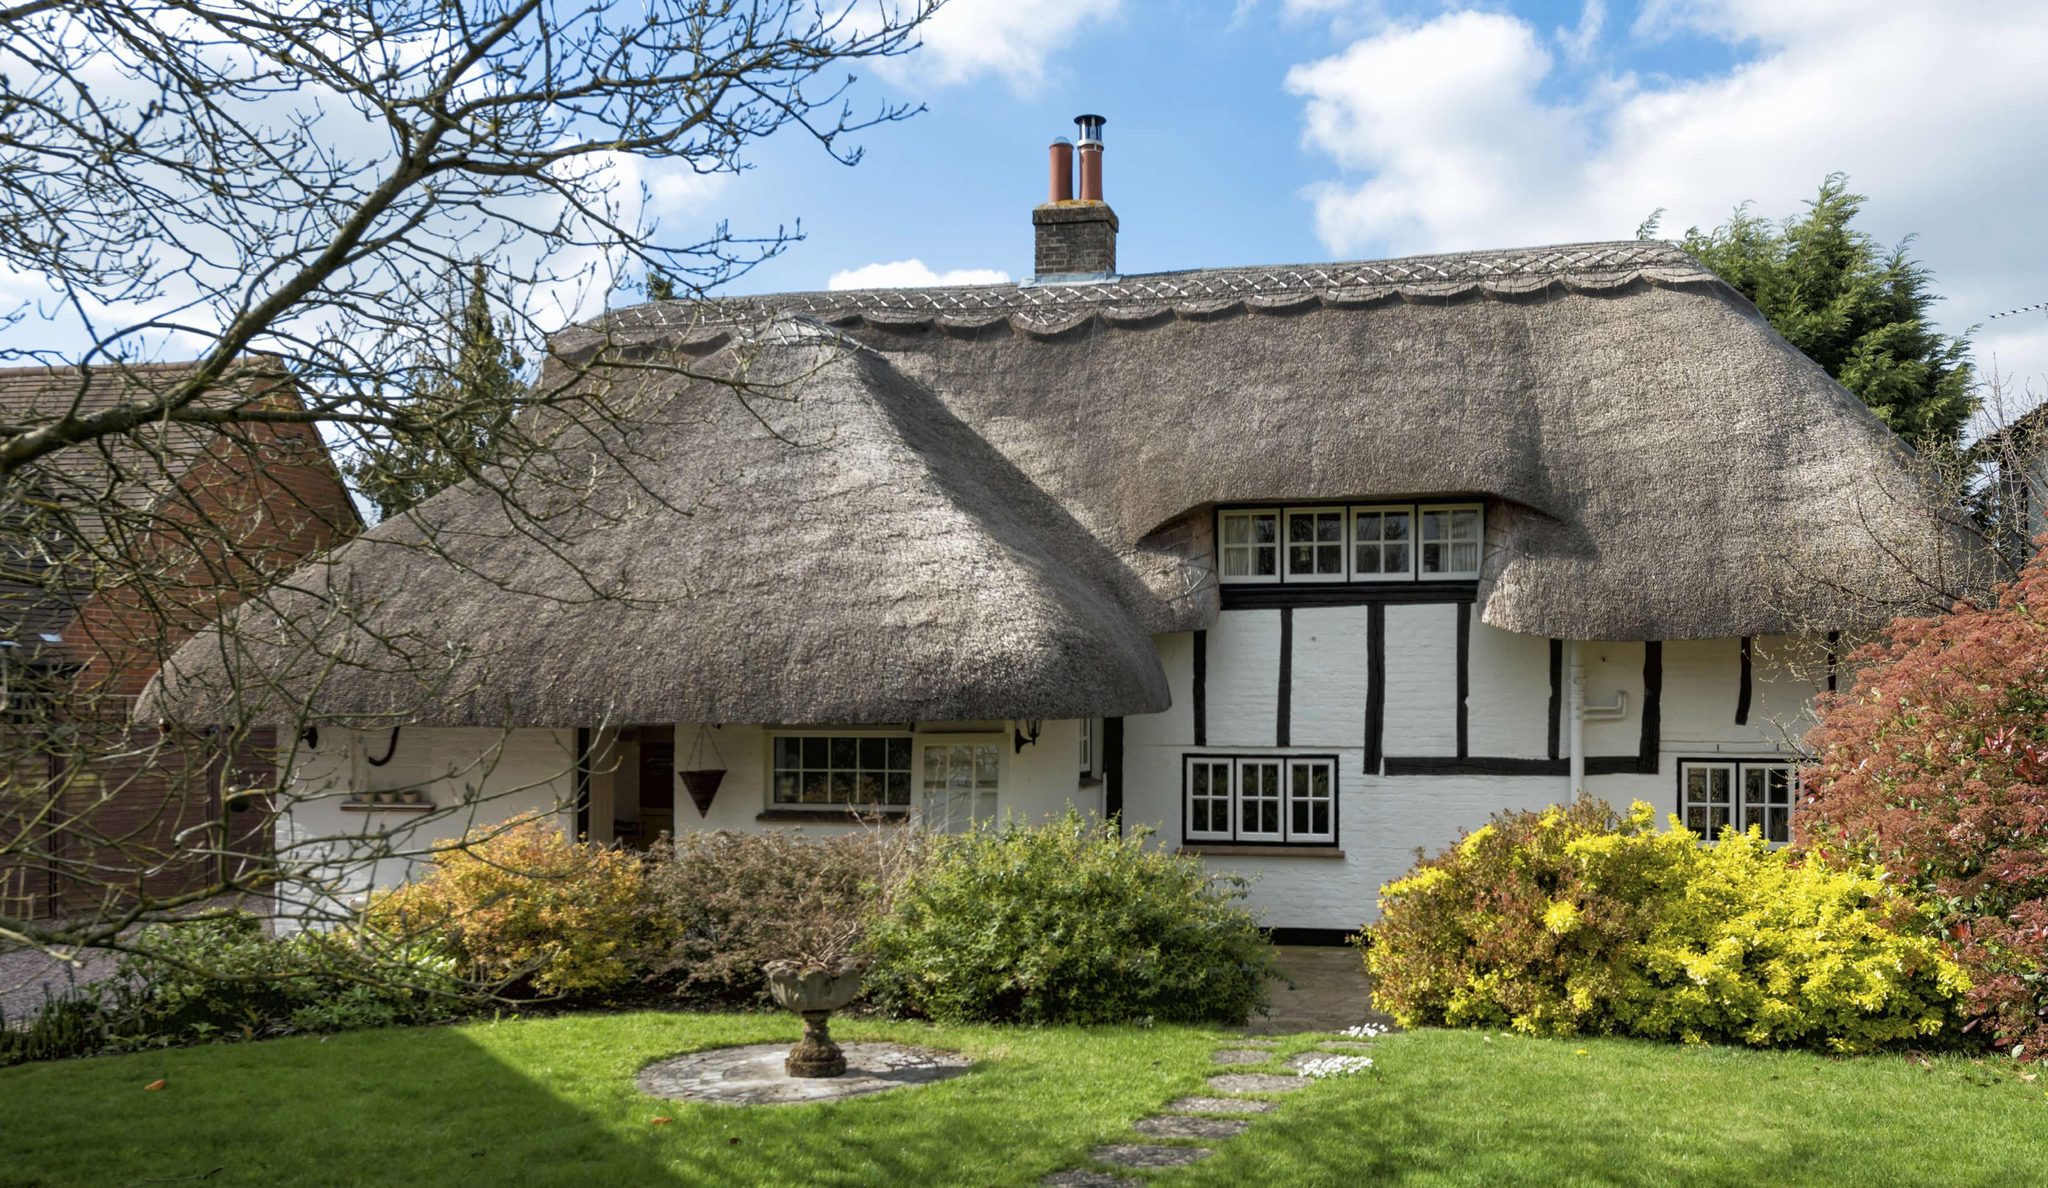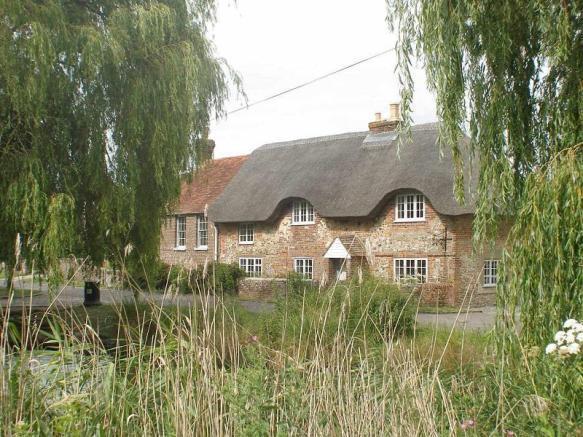The first image is the image on the left, the second image is the image on the right. Considering the images on both sides, is "A house has a red door." valid? Answer yes or no. No. The first image is the image on the left, the second image is the image on the right. Examine the images to the left and right. Is the description "The left and right image contains the same number of buildings with at least one red door." accurate? Answer yes or no. No. 